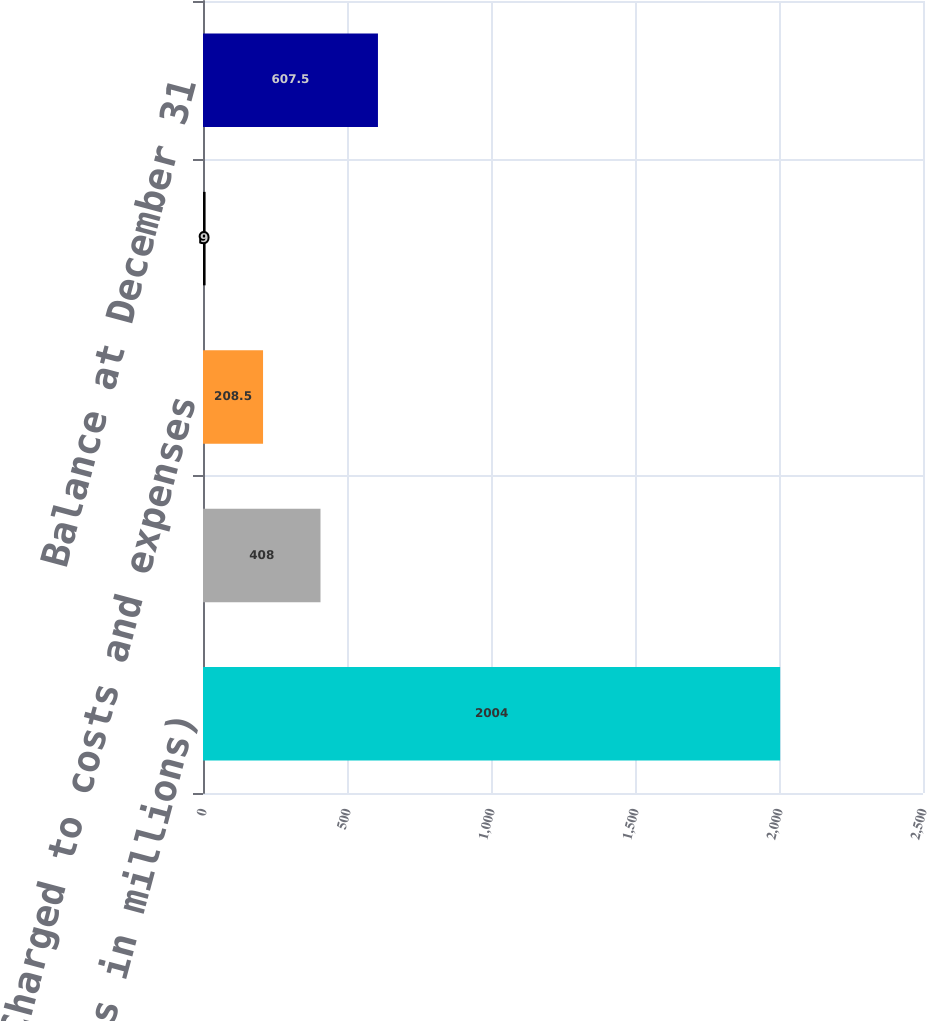Convert chart to OTSL. <chart><loc_0><loc_0><loc_500><loc_500><bar_chart><fcel>(Dollars in millions)<fcel>Balance at January 1<fcel>Charged to costs and expenses<fcel>Other adjustments<fcel>Balance at December 31<nl><fcel>2004<fcel>408<fcel>208.5<fcel>9<fcel>607.5<nl></chart> 